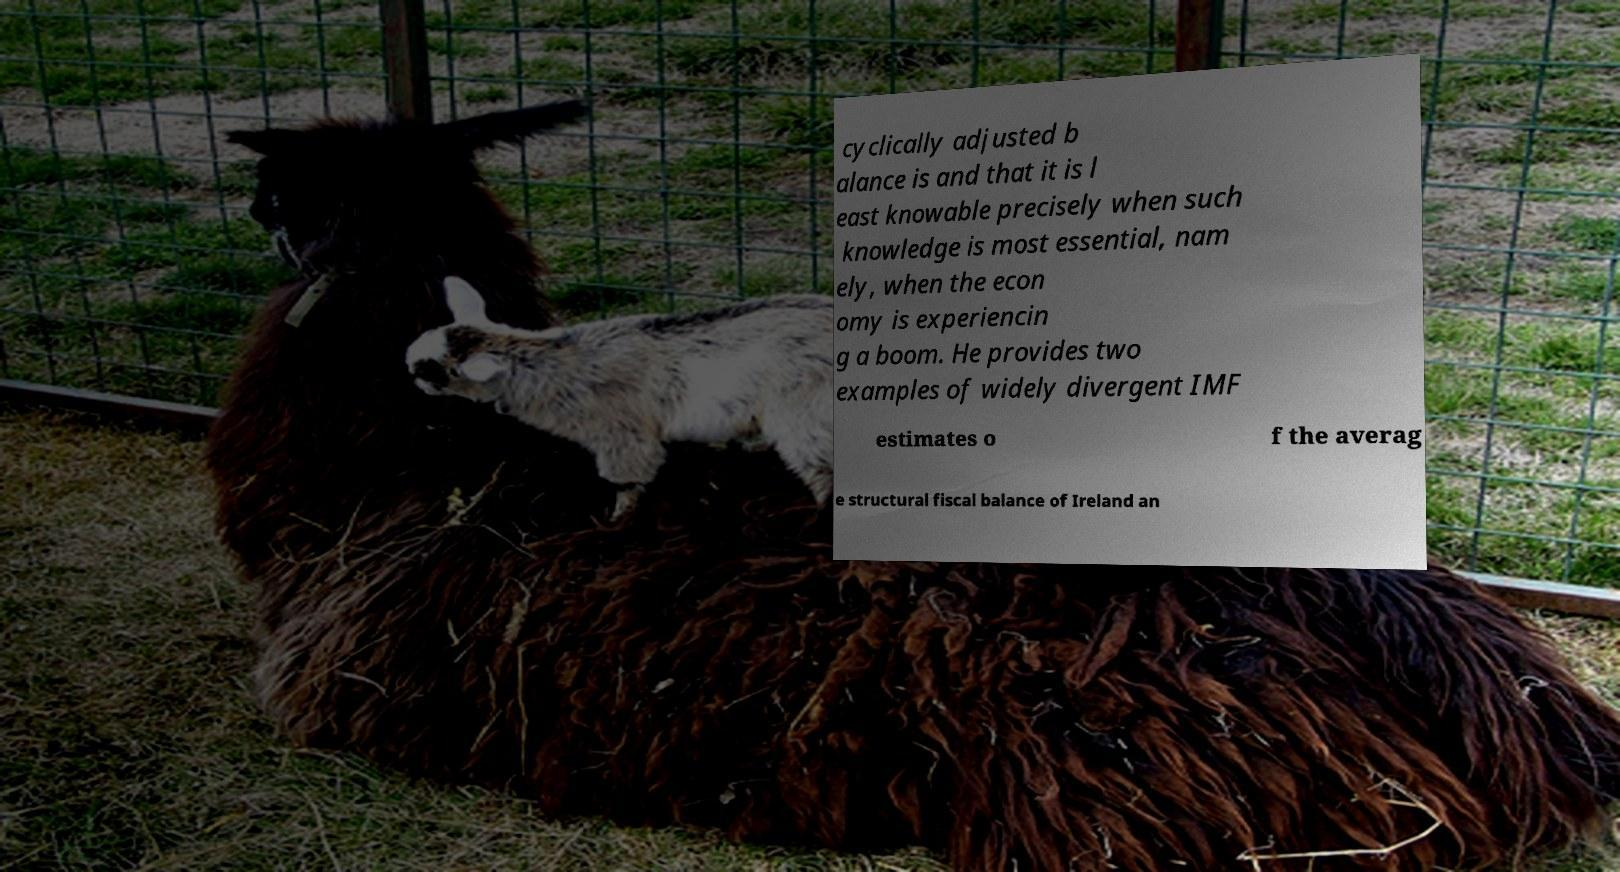Can you accurately transcribe the text from the provided image for me? cyclically adjusted b alance is and that it is l east knowable precisely when such knowledge is most essential, nam ely, when the econ omy is experiencin g a boom. He provides two examples of widely divergent IMF estimates o f the averag e structural fiscal balance of Ireland an 